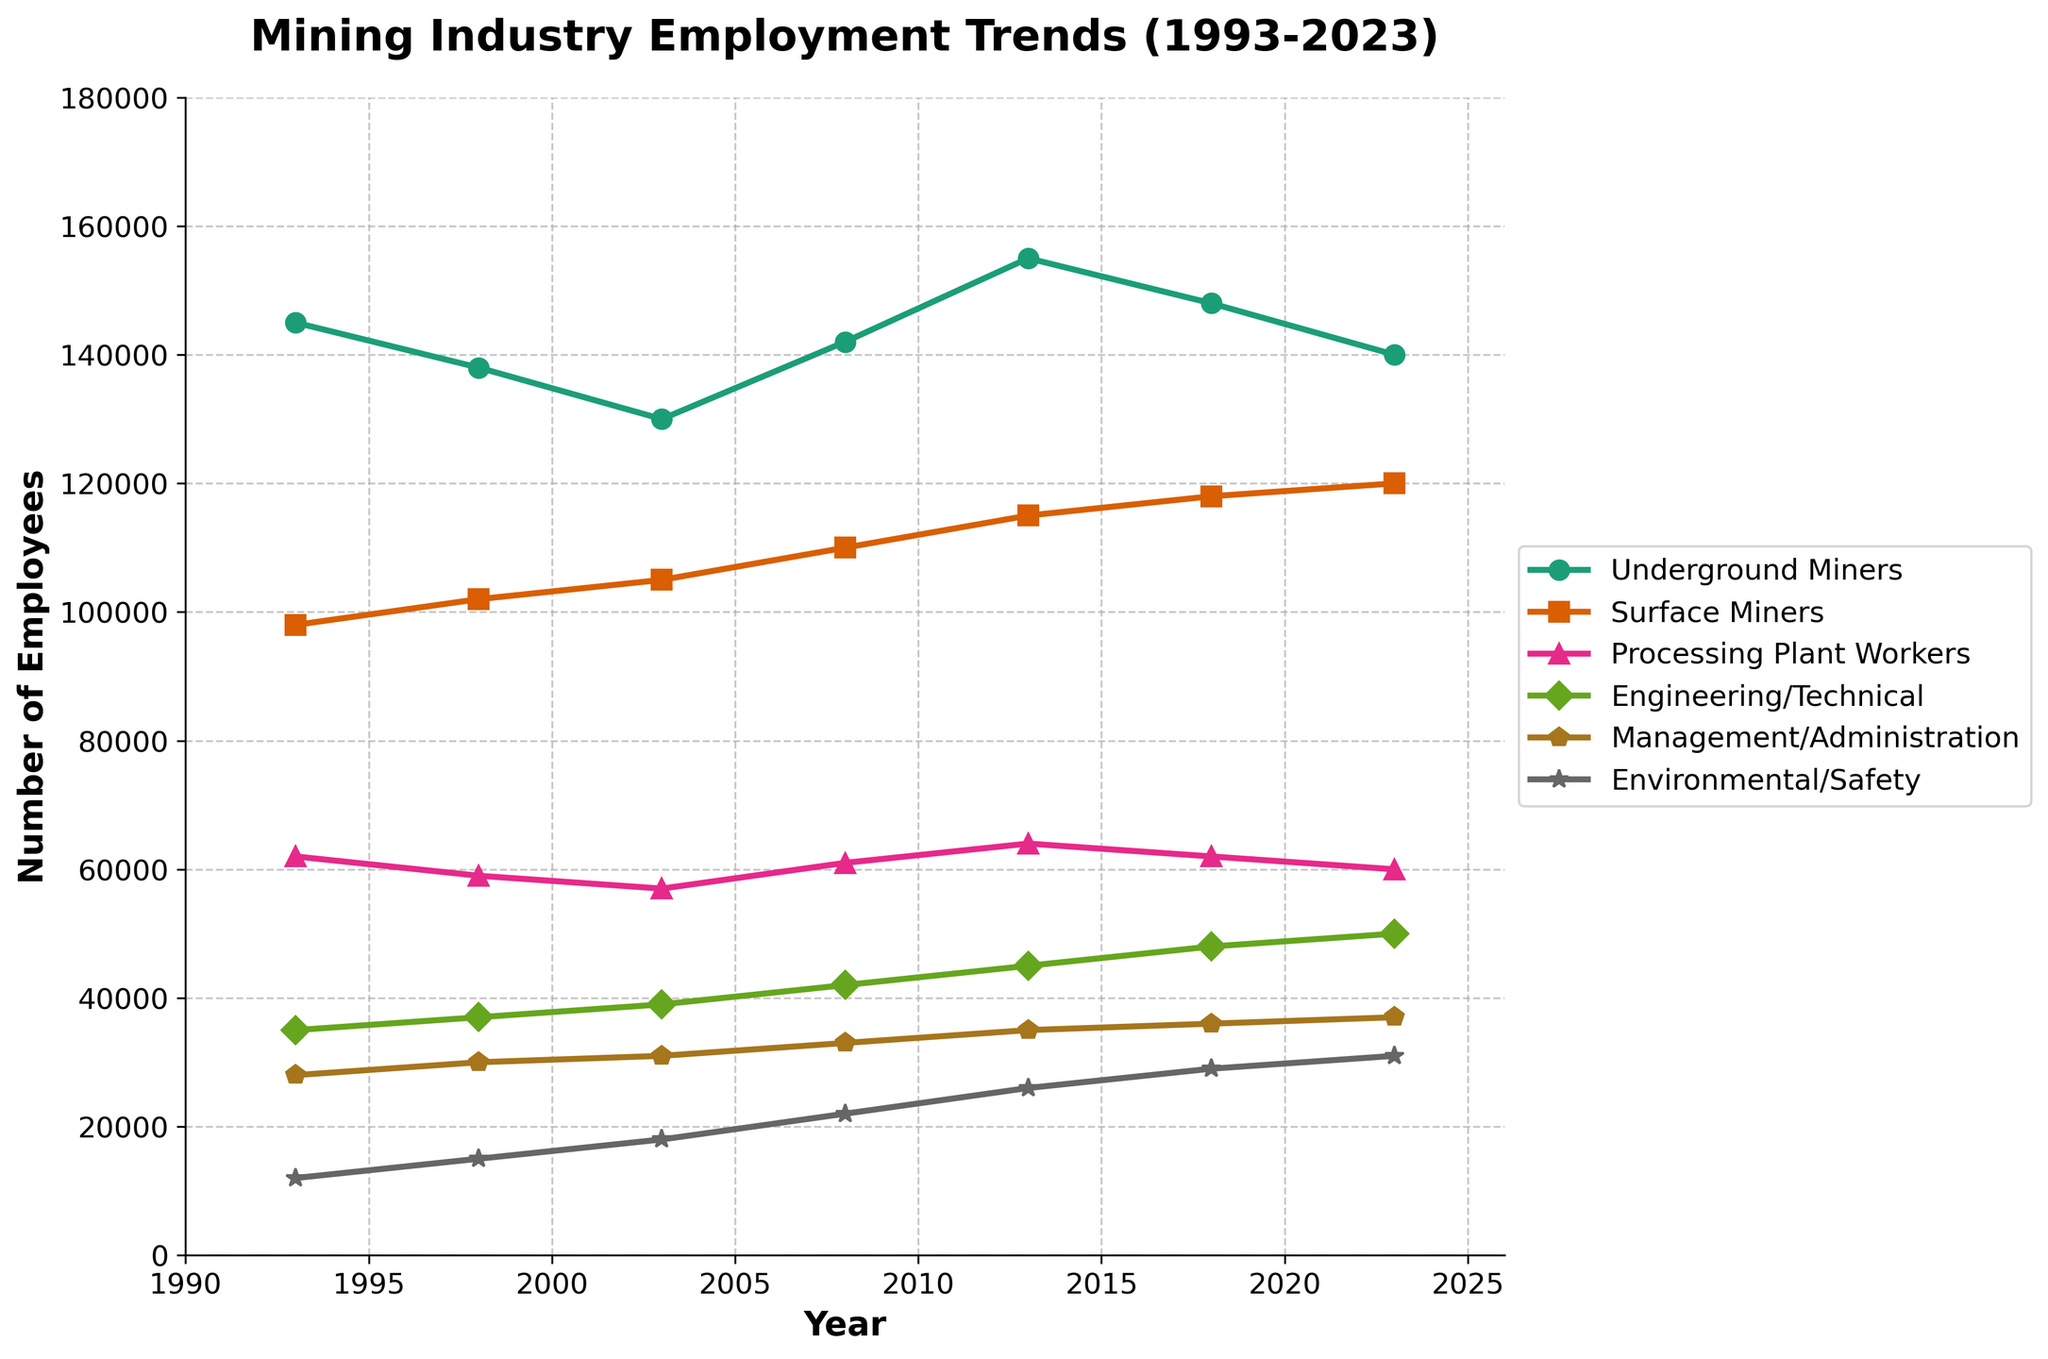What's the trend in the number of underground miners from 1993 to 2023? The number of underground miners decreased from 145,000 in 1993 to 140,000 in 2023, with slight fluctuations in between (a decrease and subsequent increase followed by a slight decrease again).
Answer: Decreasing with fluctuations How did the number of processing plant workers change between 1998 and 2013? To find this, compare the numbers for 1998 (59,000) and 2013 (64,000). The difference is 64,000 - 59,000 = 5,000, indicating an increase.
Answer: Increase by 5,000 Which job category had the largest increase in employment numbers from 1993 to 2023? Calculate the difference between 1993 and 2023 for each category: Underground Miners (-5,000), Surface Miners (22,000), Processing Plant Workers (-2,000), Engineering/Technical (15,000), Management/Administration (9,000), Environmental/Safety (19,000). The largest increase is for Surface Miners (22,000).
Answer: Surface Miners What is the average number of surface miners from 1993 to 2023? Sum the number of surface miners: 98,000 + 102,000 + 105,000 + 110,000 + 115,000 + 118,000 + 120,000 = 768,000. Divide by the number of years (7): 768,000 / 7 = 109,714.29.
Answer: 109,714.29 In which year did the engineering/technical job category see the highest employment, and what was the value? Looking at the trend, the highest value for engineering/technical is in 2023, with 50,000 employees.
Answer: 2023, 50,000 Compare the trend lines of management/administration and environmental/safety. Which had a steeper increase from 1993 to 2023? Calculate the differences for both categories between 1993 and 2023: Management/Administration (37,000 - 28,000 = 9,000), Environmental/Safety (31,000 - 12,000 = 19,000). Environmental/Safety employment had a steeper increase.
Answer: Environmental/Safety How did the employment numbers for management/administration change between 2003 and 2018? The number of management/administration employees in 2003 was 31,000, and in 2018 it was 36,000. The change is 36,000 - 31,000 = 5,000, indicating an increase.
Answer: Increase by 5,000 What is the combined number of employees in all job categories in 2008? Sum the number of employees for all categories in 2008: 142,000 (Underground Miners) + 110,000 (Surface Miners) + 61,000 (Processing Plant Workers) + 42,000 (Engineering/Technical) + 33,000 (Management/Administration) + 22,000 (Environmental/Safety) = 410,000.
Answer: 410,000 In which year did the number of underground miners experience its sharpest increase compared to the previous year, and what was the value of the increase? The sharpest increase happened between 2003 (130,000) and 2008 (142,000). The increase is 142,000 - 130,000 = 12,000, the largest among all year pairs.
Answer: 2008, 12,000 